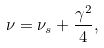<formula> <loc_0><loc_0><loc_500><loc_500>\nu = \nu _ { s } + \frac { \gamma ^ { 2 } } { 4 } ,</formula> 